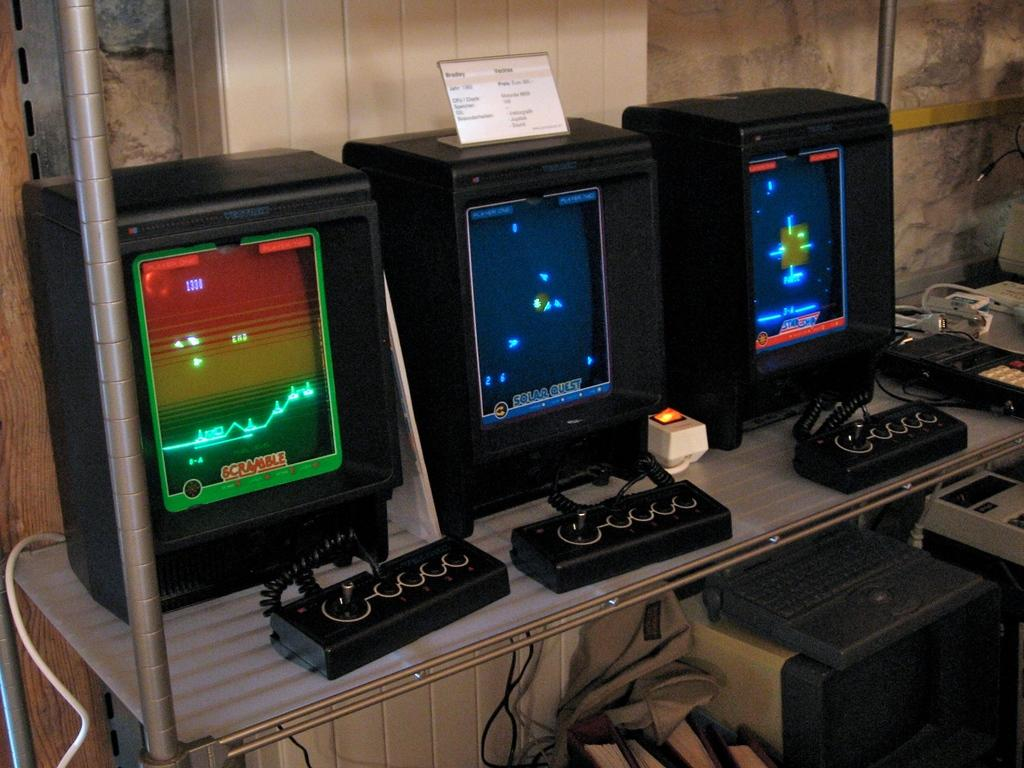<image>
Give a short and clear explanation of the subsequent image. An old video game has scramble at the bottom of the left monitor. 